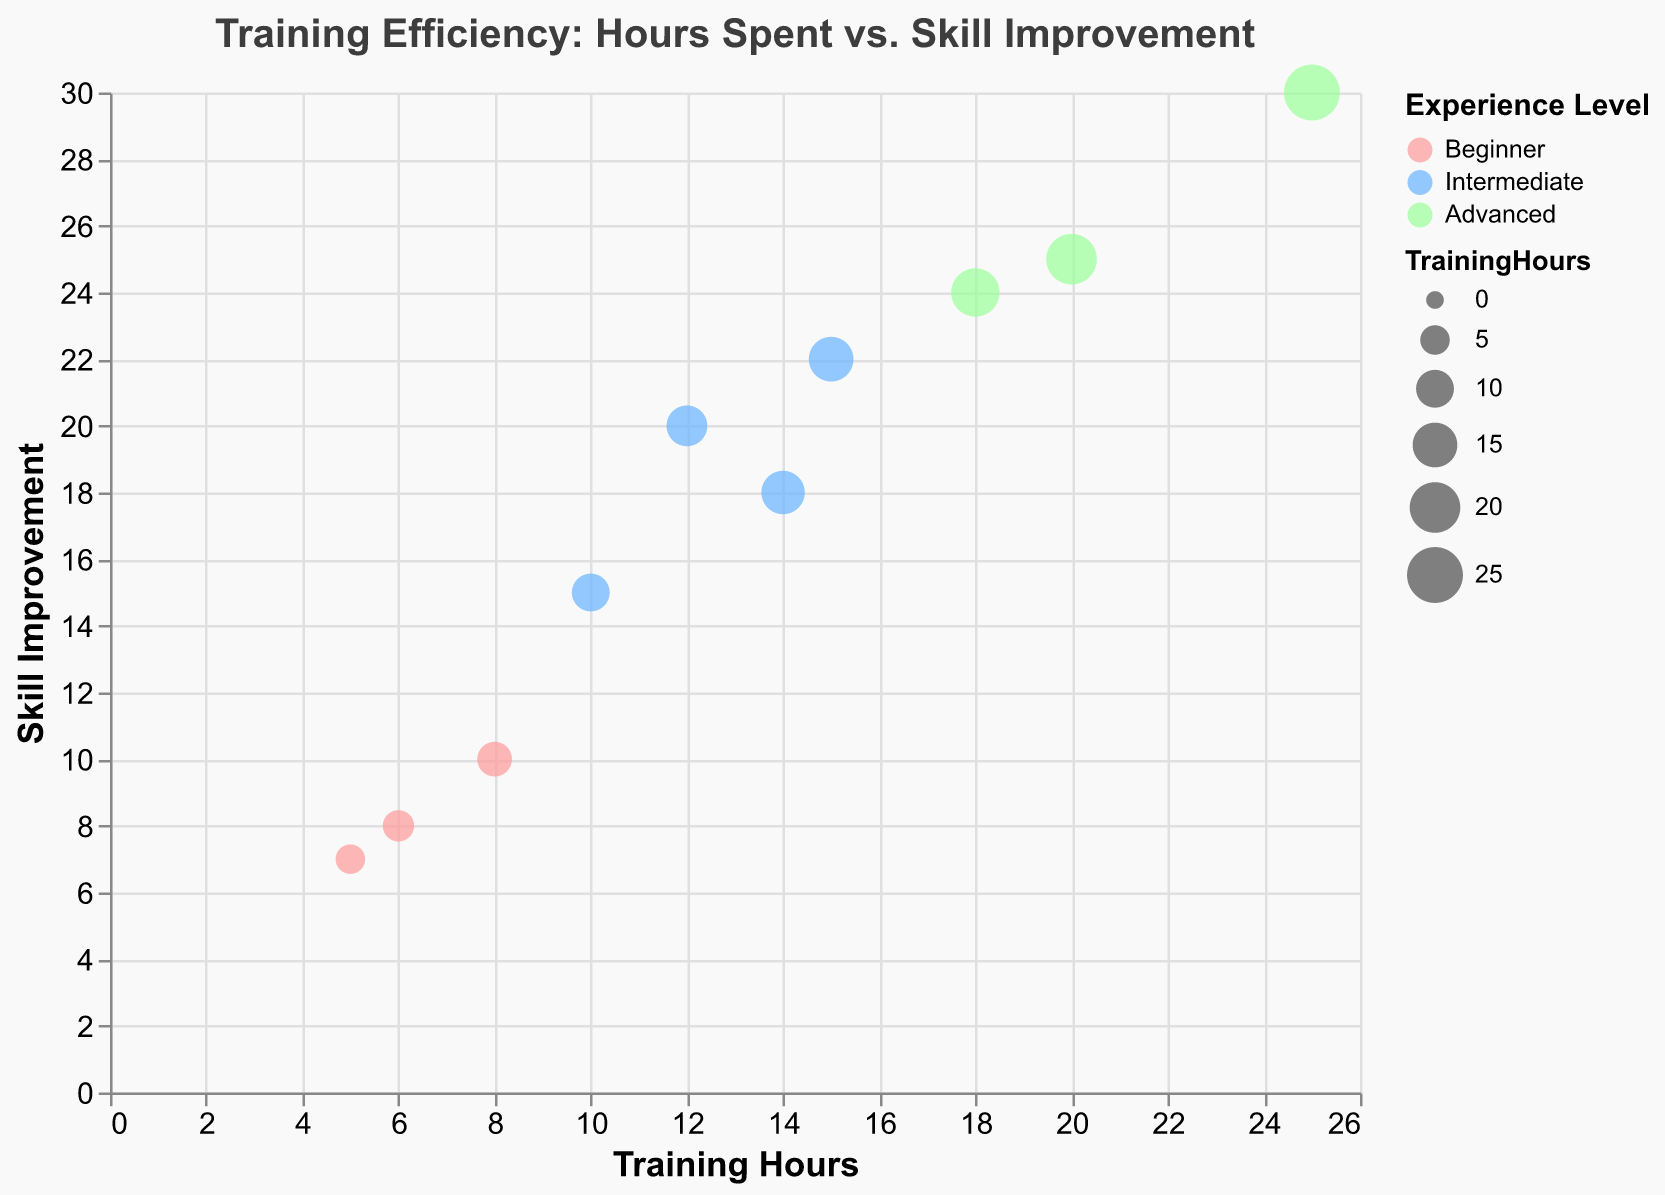What is the total number of data points in the chart? Count the total number of bubbles representing data points. Each bubble corresponds to a player. There are 10 players listed in the data.
Answer: 10 What are the axis titles in the chart? The x-axis title is "Training Hours" and the y-axis title is "Skill Improvement." These titles indicate what each axis represents.
Answer: Training Hours, Skill Improvement Which player has the highest skill improvement and what is that value? Look for the bubble that is highest on the y-axis, which represents Skill Improvement. Kevin Scott has the highest Skill Improvement value of 30.
Answer: Kevin Scott, 30 What color represents beginner-level players in the chart? The chart legend shows different colors for each Player Experience Level. The color for Beginner is described as a shade of red (#ff9999).
Answer: Red Who spent the least amount of training hours and what is that value? Identify the bubble furthest to the left on the x-axis, representing the least Training Hours. James Black spent the least with 5 hours.
Answer: James Black, 5 Which level of player experience has the largest bubbles, and why might they be the largest? The size of bubbles is proportionate to Training Hours. Advanced players have the largest bubbles, indicating they spent the most hours training. Observing the green bubbles shows they tend to be larger.
Answer: Advanced On average, how many training hours did intermediate players spend? Sum the Training Hours spent by intermediate players (10 + 15 + 12 + 14) and divide by the number of intermediate players (4). The average is (10 + 15 + 12 + 14) / 4 = 12.75 hours.
Answer: 12.75 hours Compare the skill improvement between the player with the most training hours and the player with the least. Kevin Scott has 25 Training Hours and 30 Skill Improvement. James Black has 5 Training Hours and 7 Skill Improvement. The difference in Skill Improvement is 30 - 7 = 23.
Answer: 23 What is the correlation between training hours and skill improvement in this chart? Visually assess the relationship between bubbles on the x and y axis. As Training Hours increase, Skill Improvement tends to increase, indicating a positive correlation.
Answer: Positive correlation 